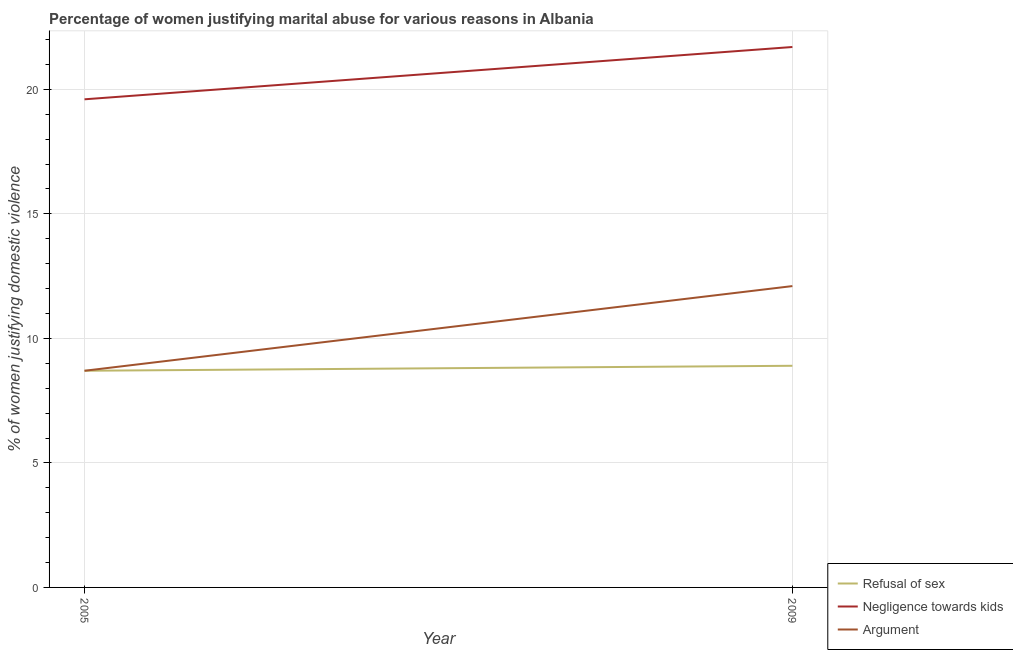Does the line corresponding to percentage of women justifying domestic violence due to arguments intersect with the line corresponding to percentage of women justifying domestic violence due to negligence towards kids?
Offer a terse response. No. Across all years, what is the maximum percentage of women justifying domestic violence due to negligence towards kids?
Your response must be concise. 21.7. Across all years, what is the minimum percentage of women justifying domestic violence due to negligence towards kids?
Your answer should be compact. 19.6. What is the total percentage of women justifying domestic violence due to negligence towards kids in the graph?
Make the answer very short. 41.3. What is the difference between the percentage of women justifying domestic violence due to refusal of sex in 2005 and that in 2009?
Provide a short and direct response. -0.2. What is the difference between the percentage of women justifying domestic violence due to refusal of sex in 2005 and the percentage of women justifying domestic violence due to negligence towards kids in 2009?
Provide a short and direct response. -13. What is the average percentage of women justifying domestic violence due to refusal of sex per year?
Offer a terse response. 8.8. In the year 2009, what is the difference between the percentage of women justifying domestic violence due to negligence towards kids and percentage of women justifying domestic violence due to refusal of sex?
Keep it short and to the point. 12.8. What is the ratio of the percentage of women justifying domestic violence due to negligence towards kids in 2005 to that in 2009?
Offer a very short reply. 0.9. Does the percentage of women justifying domestic violence due to arguments monotonically increase over the years?
Provide a succinct answer. Yes. How many lines are there?
Give a very brief answer. 3. What is the difference between two consecutive major ticks on the Y-axis?
Offer a terse response. 5. Are the values on the major ticks of Y-axis written in scientific E-notation?
Make the answer very short. No. Where does the legend appear in the graph?
Provide a short and direct response. Bottom right. What is the title of the graph?
Ensure brevity in your answer.  Percentage of women justifying marital abuse for various reasons in Albania. Does "Agricultural Nitrous Oxide" appear as one of the legend labels in the graph?
Keep it short and to the point. No. What is the label or title of the X-axis?
Make the answer very short. Year. What is the label or title of the Y-axis?
Make the answer very short. % of women justifying domestic violence. What is the % of women justifying domestic violence of Refusal of sex in 2005?
Provide a short and direct response. 8.7. What is the % of women justifying domestic violence in Negligence towards kids in 2005?
Ensure brevity in your answer.  19.6. What is the % of women justifying domestic violence in Argument in 2005?
Your response must be concise. 8.7. What is the % of women justifying domestic violence in Negligence towards kids in 2009?
Keep it short and to the point. 21.7. What is the % of women justifying domestic violence of Argument in 2009?
Ensure brevity in your answer.  12.1. Across all years, what is the maximum % of women justifying domestic violence of Refusal of sex?
Your answer should be compact. 8.9. Across all years, what is the maximum % of women justifying domestic violence of Negligence towards kids?
Provide a short and direct response. 21.7. Across all years, what is the minimum % of women justifying domestic violence in Refusal of sex?
Ensure brevity in your answer.  8.7. Across all years, what is the minimum % of women justifying domestic violence of Negligence towards kids?
Keep it short and to the point. 19.6. Across all years, what is the minimum % of women justifying domestic violence of Argument?
Make the answer very short. 8.7. What is the total % of women justifying domestic violence in Refusal of sex in the graph?
Keep it short and to the point. 17.6. What is the total % of women justifying domestic violence in Negligence towards kids in the graph?
Keep it short and to the point. 41.3. What is the total % of women justifying domestic violence in Argument in the graph?
Give a very brief answer. 20.8. What is the difference between the % of women justifying domestic violence in Argument in 2005 and that in 2009?
Provide a succinct answer. -3.4. What is the difference between the % of women justifying domestic violence in Refusal of sex in 2005 and the % of women justifying domestic violence in Negligence towards kids in 2009?
Your response must be concise. -13. What is the difference between the % of women justifying domestic violence in Refusal of sex in 2005 and the % of women justifying domestic violence in Argument in 2009?
Offer a very short reply. -3.4. What is the average % of women justifying domestic violence of Negligence towards kids per year?
Your answer should be very brief. 20.65. What is the average % of women justifying domestic violence of Argument per year?
Provide a succinct answer. 10.4. In the year 2005, what is the difference between the % of women justifying domestic violence of Refusal of sex and % of women justifying domestic violence of Negligence towards kids?
Offer a terse response. -10.9. In the year 2005, what is the difference between the % of women justifying domestic violence of Refusal of sex and % of women justifying domestic violence of Argument?
Provide a succinct answer. 0. In the year 2009, what is the difference between the % of women justifying domestic violence in Refusal of sex and % of women justifying domestic violence in Negligence towards kids?
Give a very brief answer. -12.8. In the year 2009, what is the difference between the % of women justifying domestic violence in Negligence towards kids and % of women justifying domestic violence in Argument?
Offer a terse response. 9.6. What is the ratio of the % of women justifying domestic violence in Refusal of sex in 2005 to that in 2009?
Keep it short and to the point. 0.98. What is the ratio of the % of women justifying domestic violence in Negligence towards kids in 2005 to that in 2009?
Give a very brief answer. 0.9. What is the ratio of the % of women justifying domestic violence in Argument in 2005 to that in 2009?
Ensure brevity in your answer.  0.72. What is the difference between the highest and the second highest % of women justifying domestic violence in Refusal of sex?
Keep it short and to the point. 0.2. What is the difference between the highest and the lowest % of women justifying domestic violence in Negligence towards kids?
Your response must be concise. 2.1. 